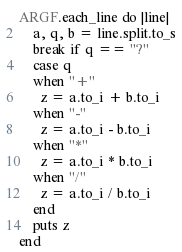<code> <loc_0><loc_0><loc_500><loc_500><_Ruby_>ARGF.each_line do |line|
    a, q, b = line.split.to_s
    break if q == "?"
    case q
    when "+"
      z = a.to_i + b.to_i
    when "-"
      z = a.to_i - b.to_i
    when "*"
      z = a.to_i * b.to_i
    when "/"
      z = a.to_i / b.to_i
    end
    puts z
end</code> 